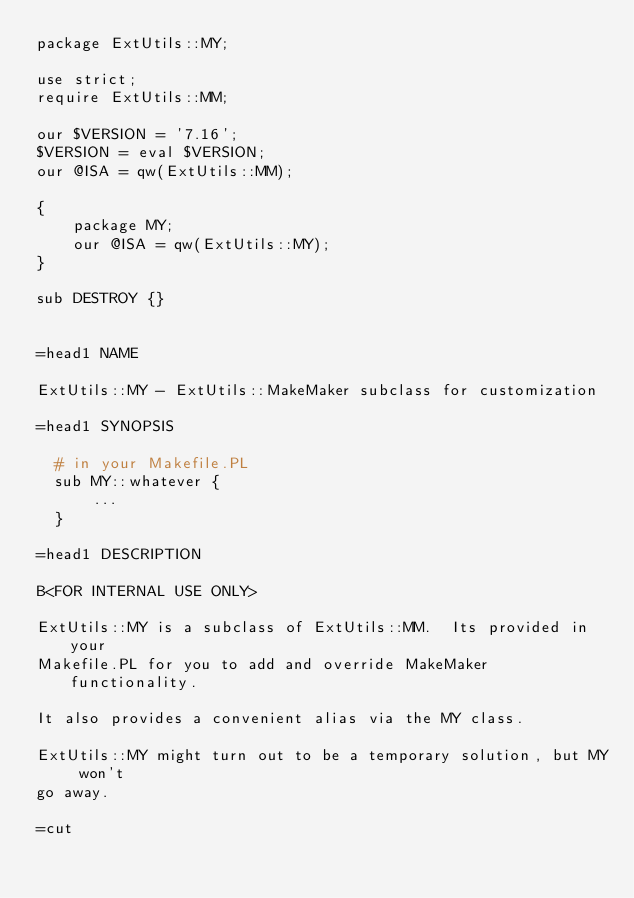<code> <loc_0><loc_0><loc_500><loc_500><_Perl_>package ExtUtils::MY;

use strict;
require ExtUtils::MM;

our $VERSION = '7.16';
$VERSION = eval $VERSION;
our @ISA = qw(ExtUtils::MM);

{
    package MY;
    our @ISA = qw(ExtUtils::MY);
}

sub DESTROY {}


=head1 NAME

ExtUtils::MY - ExtUtils::MakeMaker subclass for customization

=head1 SYNOPSIS

  # in your Makefile.PL
  sub MY::whatever {
      ...
  }

=head1 DESCRIPTION

B<FOR INTERNAL USE ONLY>

ExtUtils::MY is a subclass of ExtUtils::MM.  Its provided in your
Makefile.PL for you to add and override MakeMaker functionality.

It also provides a convenient alias via the MY class.

ExtUtils::MY might turn out to be a temporary solution, but MY won't
go away.

=cut
</code> 